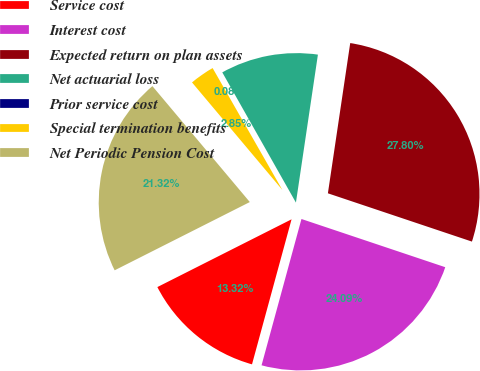Convert chart to OTSL. <chart><loc_0><loc_0><loc_500><loc_500><pie_chart><fcel>Service cost<fcel>Interest cost<fcel>Expected return on plan assets<fcel>Net actuarial loss<fcel>Prior service cost<fcel>Special termination benefits<fcel>Net Periodic Pension Cost<nl><fcel>13.32%<fcel>24.09%<fcel>27.8%<fcel>10.54%<fcel>0.08%<fcel>2.85%<fcel>21.32%<nl></chart> 